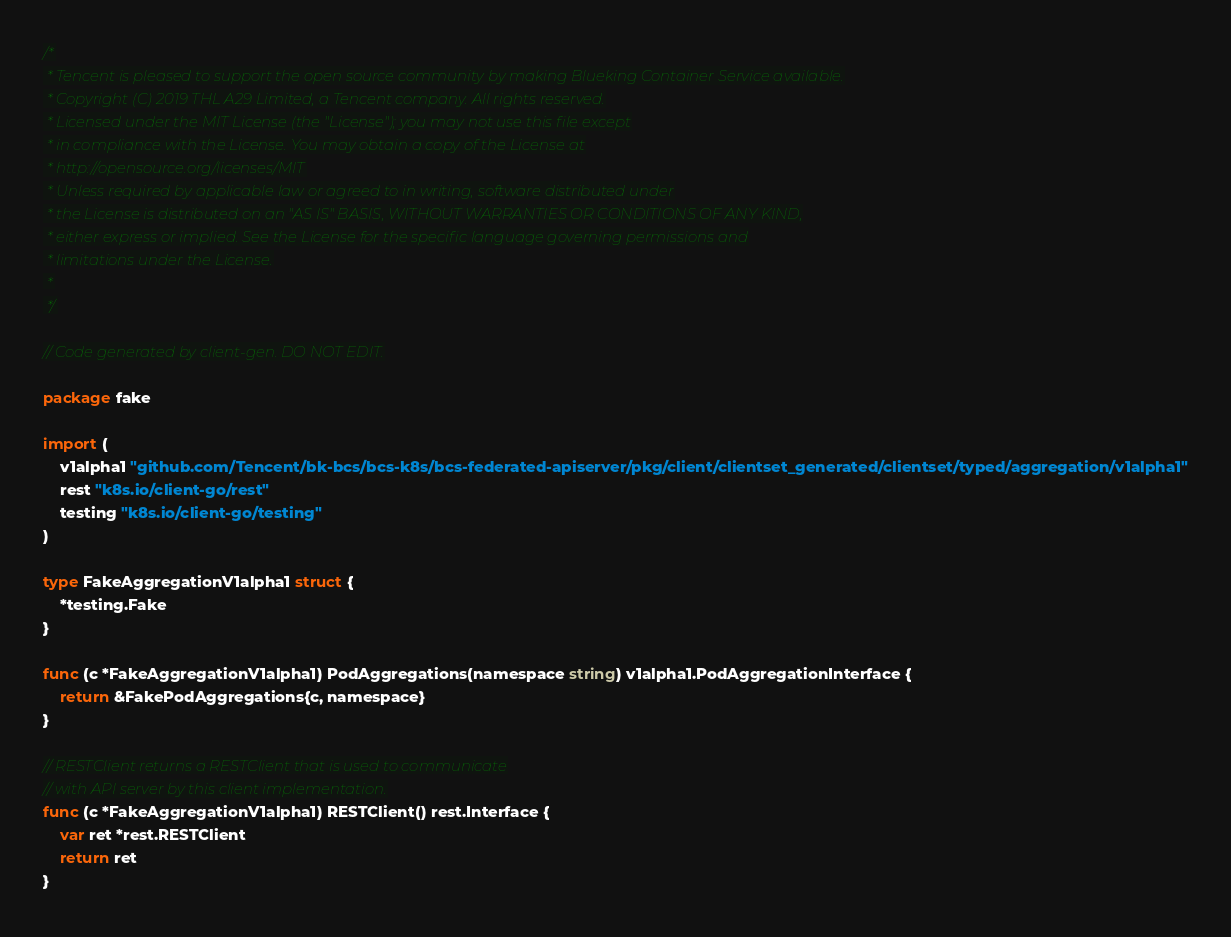<code> <loc_0><loc_0><loc_500><loc_500><_Go_>/*
 * Tencent is pleased to support the open source community by making Blueking Container Service available.
 * Copyright (C) 2019 THL A29 Limited, a Tencent company. All rights reserved.
 * Licensed under the MIT License (the "License"); you may not use this file except
 * in compliance with the License. You may obtain a copy of the License at
 * http://opensource.org/licenses/MIT
 * Unless required by applicable law or agreed to in writing, software distributed under
 * the License is distributed on an "AS IS" BASIS, WITHOUT WARRANTIES OR CONDITIONS OF ANY KIND,
 * either express or implied. See the License for the specific language governing permissions and
 * limitations under the License.
 *
 */

// Code generated by client-gen. DO NOT EDIT.

package fake

import (
	v1alpha1 "github.com/Tencent/bk-bcs/bcs-k8s/bcs-federated-apiserver/pkg/client/clientset_generated/clientset/typed/aggregation/v1alpha1"
	rest "k8s.io/client-go/rest"
	testing "k8s.io/client-go/testing"
)

type FakeAggregationV1alpha1 struct {
	*testing.Fake
}

func (c *FakeAggregationV1alpha1) PodAggregations(namespace string) v1alpha1.PodAggregationInterface {
	return &FakePodAggregations{c, namespace}
}

// RESTClient returns a RESTClient that is used to communicate
// with API server by this client implementation.
func (c *FakeAggregationV1alpha1) RESTClient() rest.Interface {
	var ret *rest.RESTClient
	return ret
}
</code> 